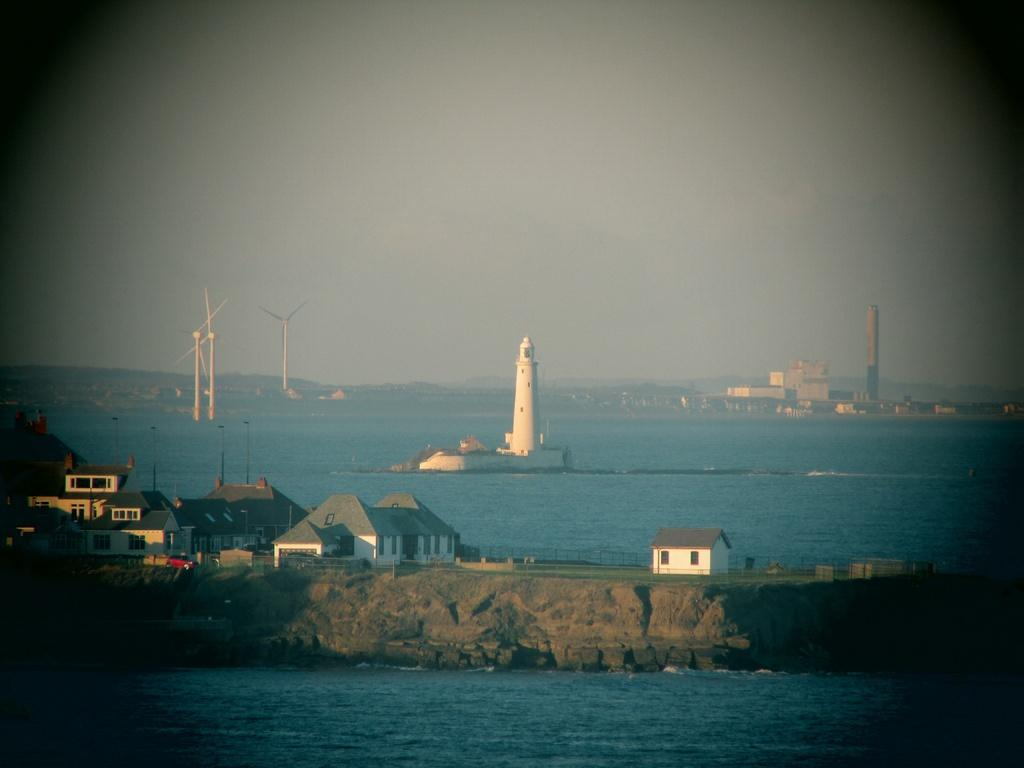What type of structures can be seen in the image? There are houses, a tower, and buildings in the image. Where are the windmills located in the image? The windmills are visible in the middle of the sea in the image. What is visible at the top of the image? The sky is visible at the top of the image. What type of rice is being cooked in the image? There is no rice present in the image. Where is the playground located in the image? There is no playground present in the image. 